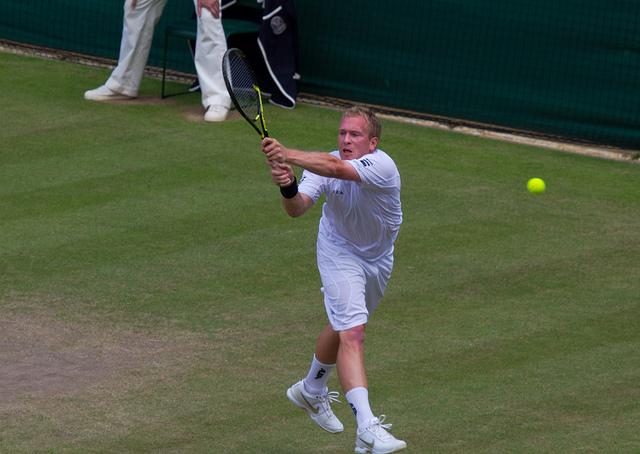Is the man's face red?
Concise answer only. Yes. What are they playing?
Be succinct. Tennis. Is this man playing the game correctly?
Answer briefly. Yes. 